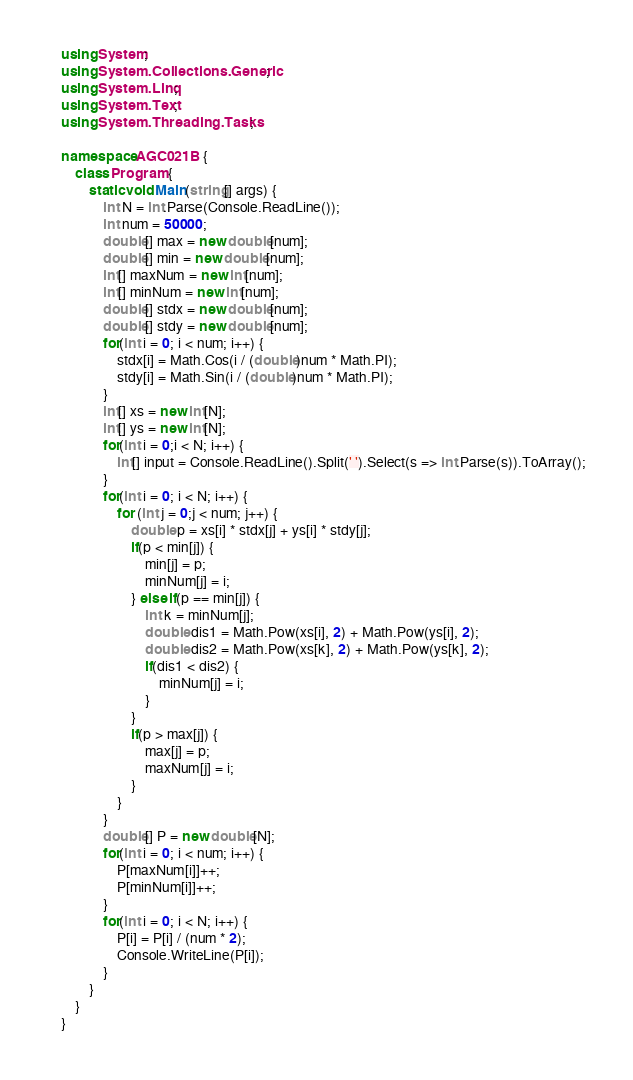Convert code to text. <code><loc_0><loc_0><loc_500><loc_500><_C#_>using System;
using System.Collections.Generic;
using System.Linq;
using System.Text;
using System.Threading.Tasks;

namespace AGC021B {
    class Program {
        static void Main(string[] args) {
            int N = int.Parse(Console.ReadLine());
            int num = 50000;
            double[] max = new double[num];
            double[] min = new double[num];
            int[] maxNum = new int[num];
            int[] minNum = new int[num];
            double[] stdx = new double[num];
            double[] stdy = new double[num];
            for(int i = 0; i < num; i++) {
                stdx[i] = Math.Cos(i / (double)num * Math.PI);
                stdy[i] = Math.Sin(i / (double)num * Math.PI);
            }
            int[] xs = new int[N];
            int[] ys = new int[N];
            for(int i = 0;i < N; i++) {
                int[] input = Console.ReadLine().Split(' ').Select(s => int.Parse(s)).ToArray();
            }
            for(int i = 0; i < N; i++) {
                for (int j = 0;j < num; j++) {
                    double p = xs[i] * stdx[j] + ys[i] * stdy[j];
                    if(p < min[j]) {
                        min[j] = p;
                        minNum[j] = i;
                    } else if(p == min[j]) {
                        int k = minNum[j];
                        double dis1 = Math.Pow(xs[i], 2) + Math.Pow(ys[i], 2);
                        double dis2 = Math.Pow(xs[k], 2) + Math.Pow(ys[k], 2);
                        if(dis1 < dis2) {
                            minNum[j] = i;
                        }
                    }
                    if(p > max[j]) {
                        max[j] = p;
                        maxNum[j] = i;
                    }
                }
            }
            double[] P = new double[N];
            for(int i = 0; i < num; i++) {
                P[maxNum[i]]++;
                P[minNum[i]]++;
            }
            for(int i = 0; i < N; i++) {
                P[i] = P[i] / (num * 2);
                Console.WriteLine(P[i]);
            }
        }
    }
}</code> 